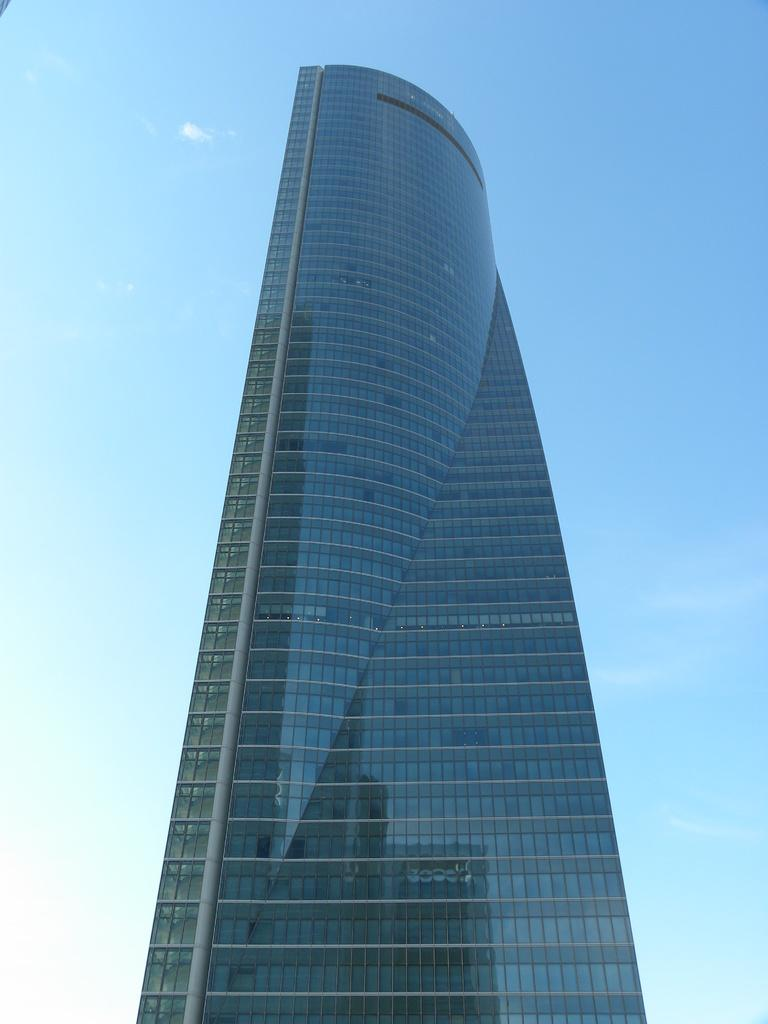What is the main subject in the center of the image? There is a building in the center of the image. What can be seen in the background of the image? There is sky visible in the background of the image. What is present in the sky in the image? There are clouds in the sky. How many sisters are sitting on the sofa in the image? There is no sofa or sisters present in the image. Is there a baseball game happening in the background of the image? There is no baseball game or any reference to sports in the image. 